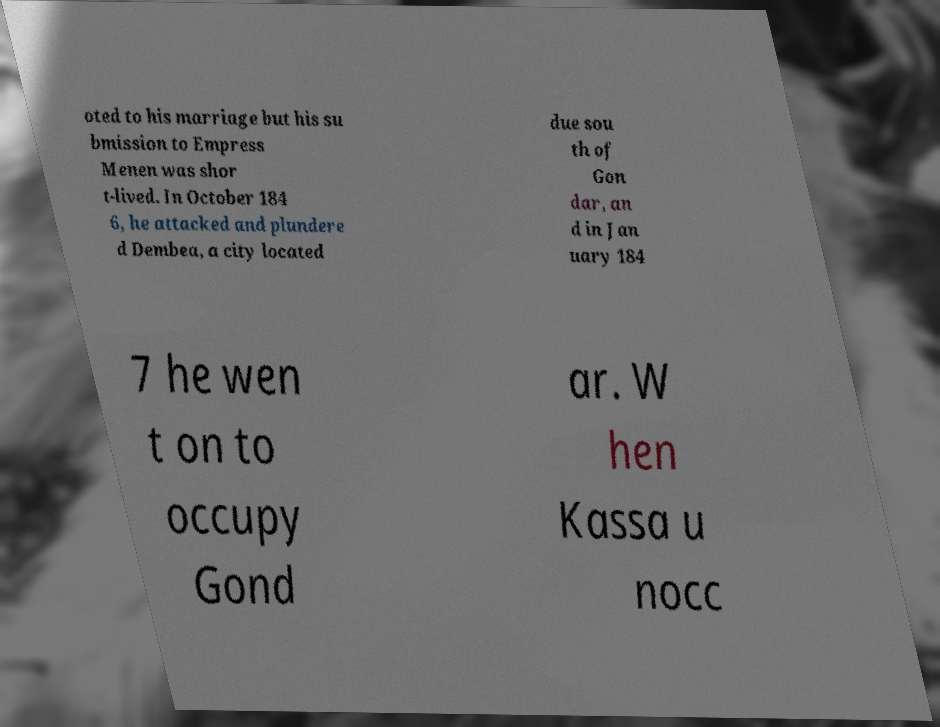Can you read and provide the text displayed in the image?This photo seems to have some interesting text. Can you extract and type it out for me? oted to his marriage but his su bmission to Empress Menen was shor t-lived. In October 184 6, he attacked and plundere d Dembea, a city located due sou th of Gon dar, an d in Jan uary 184 7 he wen t on to occupy Gond ar. W hen Kassa u nocc 